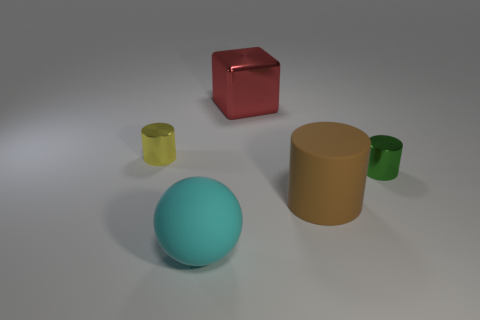Add 4 large green spheres. How many objects exist? 9 Subtract all blocks. How many objects are left? 4 Add 5 shiny cylinders. How many shiny cylinders are left? 7 Add 1 big blue metallic things. How many big blue metallic things exist? 1 Subtract 0 gray blocks. How many objects are left? 5 Subtract all big rubber cylinders. Subtract all large red metal objects. How many objects are left? 3 